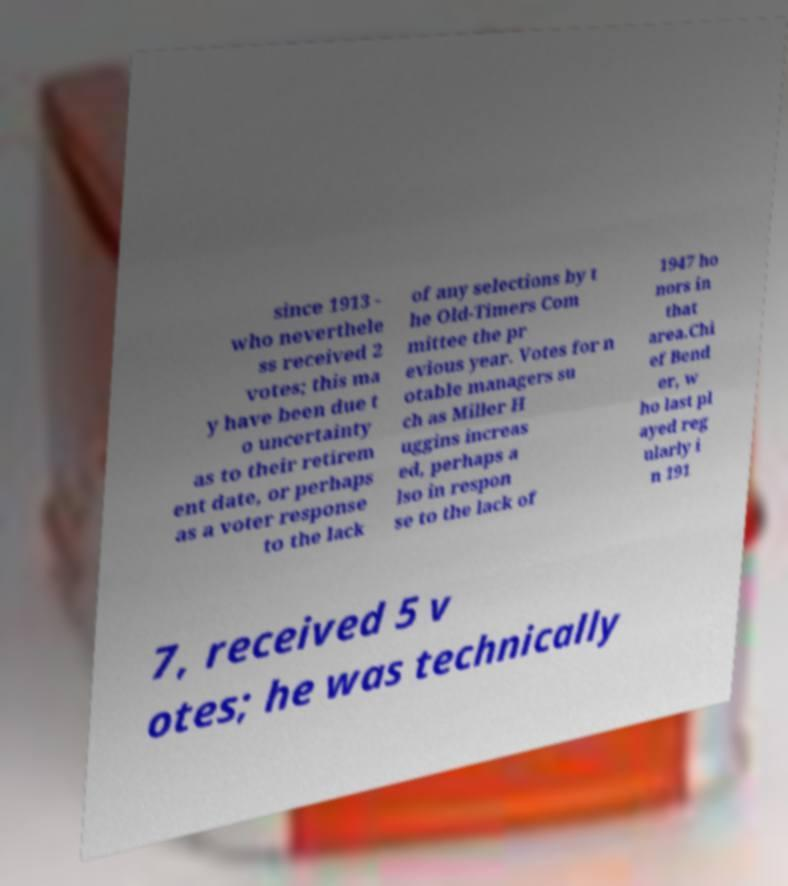Can you accurately transcribe the text from the provided image for me? since 1913 - who neverthele ss received 2 votes; this ma y have been due t o uncertainty as to their retirem ent date, or perhaps as a voter response to the lack of any selections by t he Old-Timers Com mittee the pr evious year. Votes for n otable managers su ch as Miller H uggins increas ed, perhaps a lso in respon se to the lack of 1947 ho nors in that area.Chi ef Bend er, w ho last pl ayed reg ularly i n 191 7, received 5 v otes; he was technically 